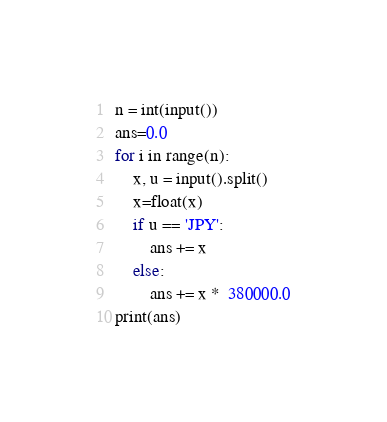Convert code to text. <code><loc_0><loc_0><loc_500><loc_500><_Python_>n = int(input())
ans=0.0
for i in range(n):
    x, u = input().split()
    x=float(x)
    if u == 'JPY':
        ans += x
    else:
        ans += x *  380000.0
print(ans)

</code> 